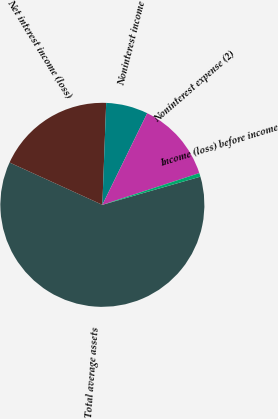<chart> <loc_0><loc_0><loc_500><loc_500><pie_chart><fcel>Total average assets<fcel>Net interest income (loss)<fcel>Noninterest income<fcel>Noninterest expense (2)<fcel>Income (loss) before income<nl><fcel>61.27%<fcel>18.79%<fcel>6.65%<fcel>12.72%<fcel>0.58%<nl></chart> 